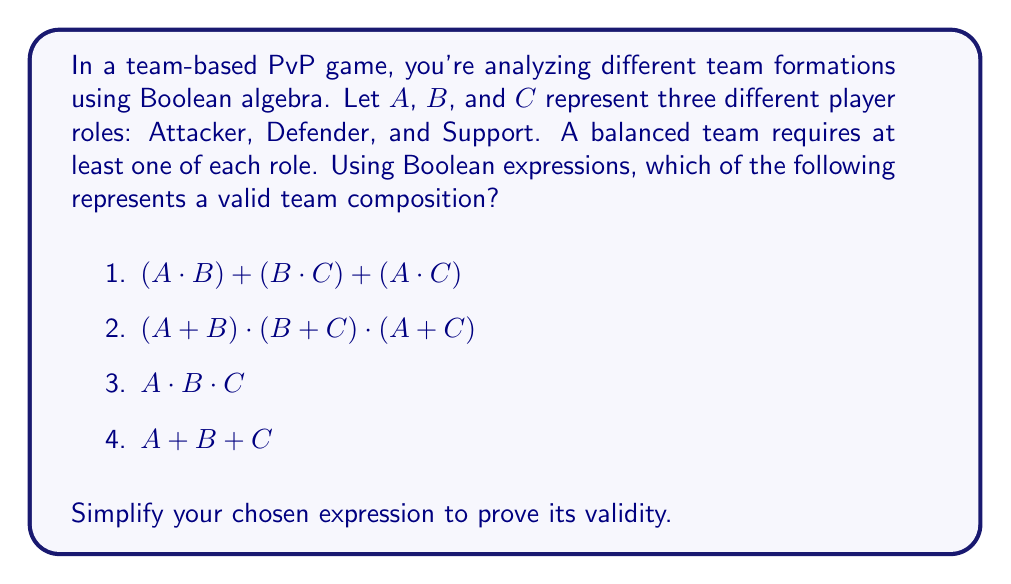Could you help me with this problem? Let's analyze each expression:

1) $(A \cdot B) + (B \cdot C) + (A \cdot C)$
   This expression represents having either (A and B) or (B and C) or (A and C). It doesn't guarantee all three roles are present.

2) $(A + B) \cdot (B + C) \cdot (A + C)$
   This is the correct expression. Let's simplify it:
   
   $$(A + B) \cdot (B + C) \cdot (A + C)$$
   $$= (A \cdot B + A \cdot C + B \cdot B + B \cdot C) \cdot (A + C)$$
   $$= (A \cdot B + A \cdot C + B + B \cdot C) \cdot (A + C)$$
   $$= A \cdot B \cdot A + A \cdot B \cdot C + A \cdot C \cdot A + A \cdot C \cdot C + B \cdot A + B \cdot C + B \cdot C \cdot A + B \cdot C \cdot C$$
   $$= A \cdot B + A \cdot B \cdot C + A \cdot C + B \cdot A + B \cdot C$$
   $$= A \cdot B + A \cdot C + B \cdot C$$

   This simplified form ensures at least one of each role is present.

3) $A \cdot B \cdot C$
   This expression represents having exactly one of each role, which is valid but more restrictive than necessary.

4) $A + B + C$
   This expression represents having at least one of the roles, but doesn't guarantee all three are present.

Therefore, expression 2 is the most appropriate representation of a valid team composition.
Answer: $(A + B) \cdot (B + C) \cdot (A + C)$ 